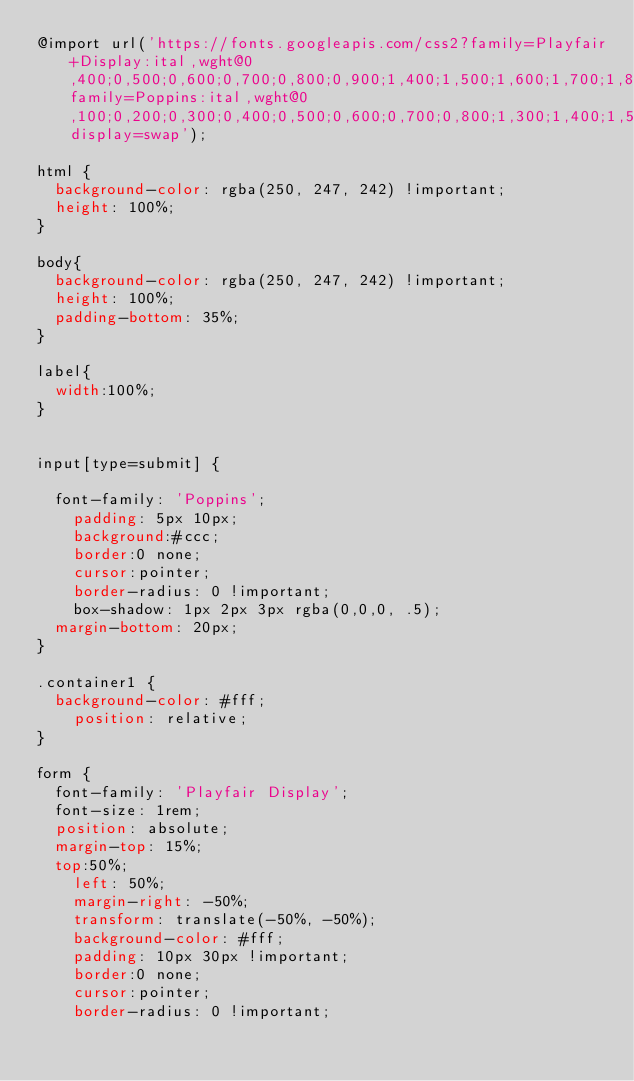Convert code to text. <code><loc_0><loc_0><loc_500><loc_500><_CSS_>@import url('https://fonts.googleapis.com/css2?family=Playfair+Display:ital,wght@0,400;0,500;0,600;0,700;0,800;0,900;1,400;1,500;1,600;1,700;1,800;1,900&family=Poppins:ital,wght@0,100;0,200;0,300;0,400;0,500;0,600;0,700;0,800;1,300;1,400;1,500;1,600;1,700;1,800&display=swap');

html {
	background-color: rgba(250, 247, 242) !important;
	height: 100%;
}

body{
	background-color: rgba(250, 247, 242) !important;
	height: 100%;
	padding-bottom: 35%;
}

label{
	width:100%;
}


input[type=submit] {

	font-family: 'Poppins';
    padding: 5px 10px;
    background:#ccc; 
    border:0 none;
    cursor:pointer;
    border-radius: 0 !important;
    box-shadow: 1px 2px 3px rgba(0,0,0, .5);
 	margin-bottom: 20px;
}

.container1 {
 	background-color: #fff;
    position: relative;
}

form {
	font-family: 'Playfair Display';
	font-size: 1rem;
	position: absolute;
	margin-top: 15%;
	top:50%;
    left: 50%;
    margin-right: -50%;
    transform: translate(-50%, -50%);
    background-color: #fff;
    padding: 10px 30px !important;
    border:0 none;
    cursor:pointer;
    border-radius: 0 !important;</code> 